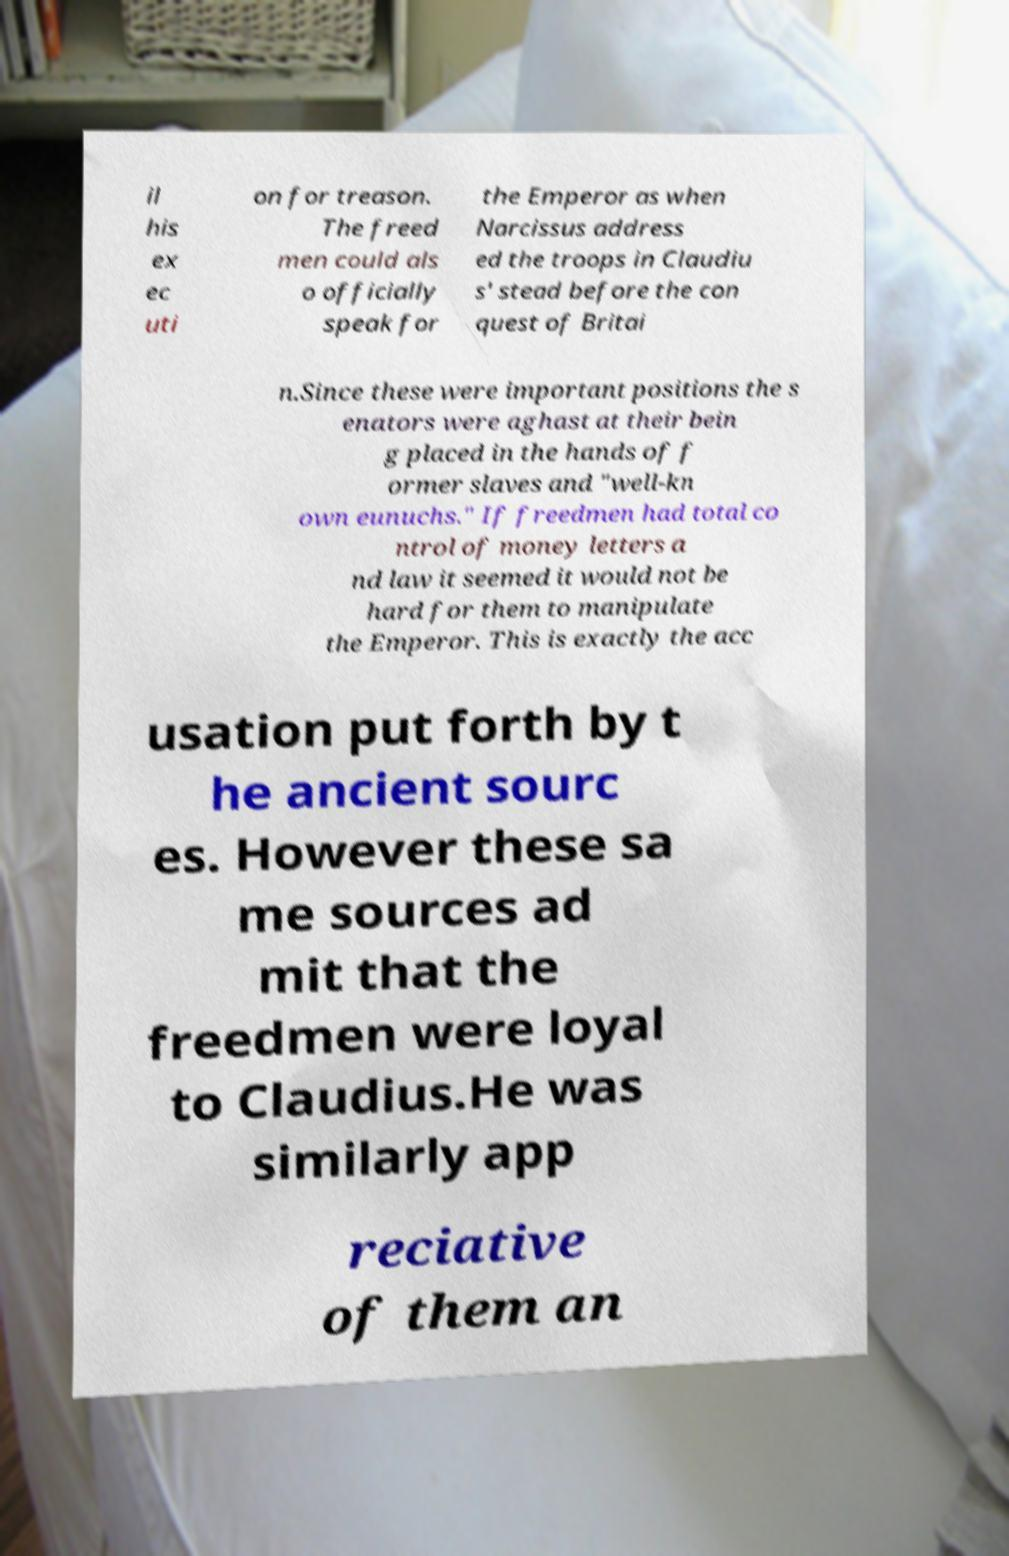Can you read and provide the text displayed in the image?This photo seems to have some interesting text. Can you extract and type it out for me? il his ex ec uti on for treason. The freed men could als o officially speak for the Emperor as when Narcissus address ed the troops in Claudiu s' stead before the con quest of Britai n.Since these were important positions the s enators were aghast at their bein g placed in the hands of f ormer slaves and "well-kn own eunuchs." If freedmen had total co ntrol of money letters a nd law it seemed it would not be hard for them to manipulate the Emperor. This is exactly the acc usation put forth by t he ancient sourc es. However these sa me sources ad mit that the freedmen were loyal to Claudius.He was similarly app reciative of them an 